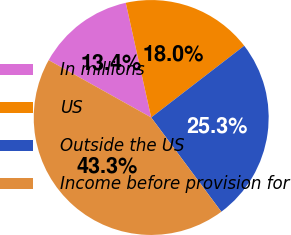Convert chart. <chart><loc_0><loc_0><loc_500><loc_500><pie_chart><fcel>In millions<fcel>US<fcel>Outside the US<fcel>Income before provision for<nl><fcel>13.41%<fcel>18.02%<fcel>25.27%<fcel>43.3%<nl></chart> 